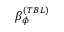Convert formula to latex. <formula><loc_0><loc_0><loc_500><loc_500>\beta _ { \phi } ^ { ( T B L ) }</formula> 